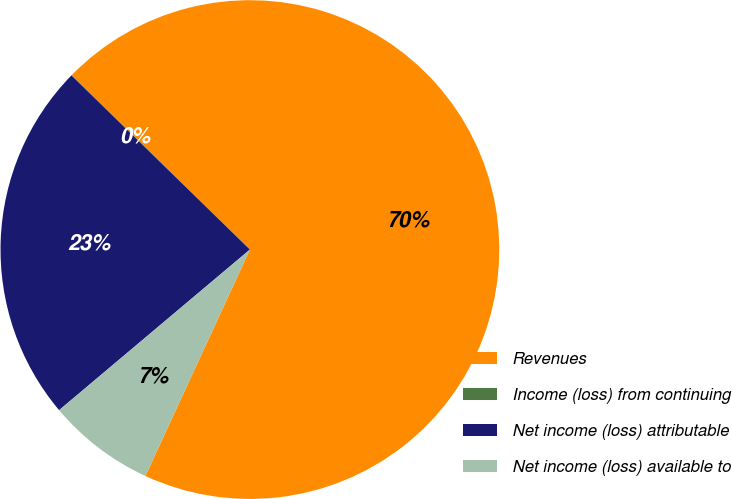Convert chart. <chart><loc_0><loc_0><loc_500><loc_500><pie_chart><fcel>Revenues<fcel>Income (loss) from continuing<fcel>Net income (loss) attributable<fcel>Net income (loss) available to<nl><fcel>69.55%<fcel>0.03%<fcel>23.44%<fcel>6.98%<nl></chart> 